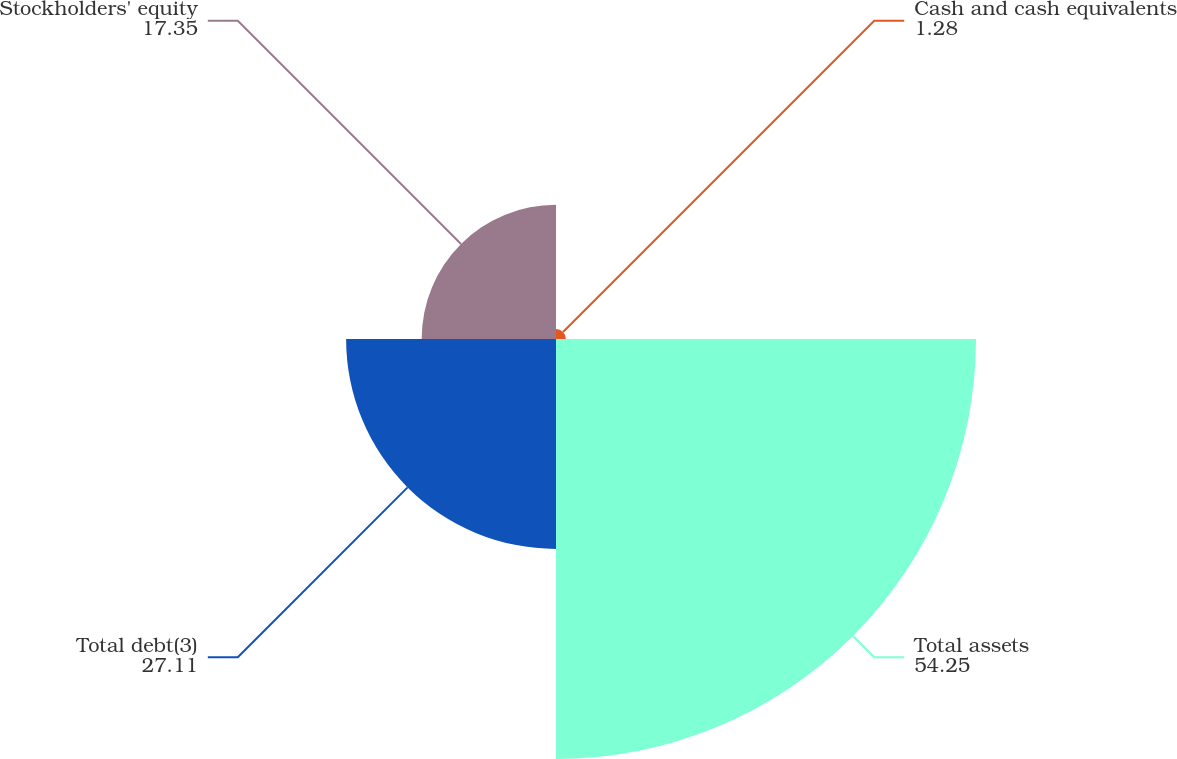Convert chart. <chart><loc_0><loc_0><loc_500><loc_500><pie_chart><fcel>Cash and cash equivalents<fcel>Total assets<fcel>Total debt(3)<fcel>Stockholders' equity<nl><fcel>1.28%<fcel>54.25%<fcel>27.11%<fcel>17.35%<nl></chart> 